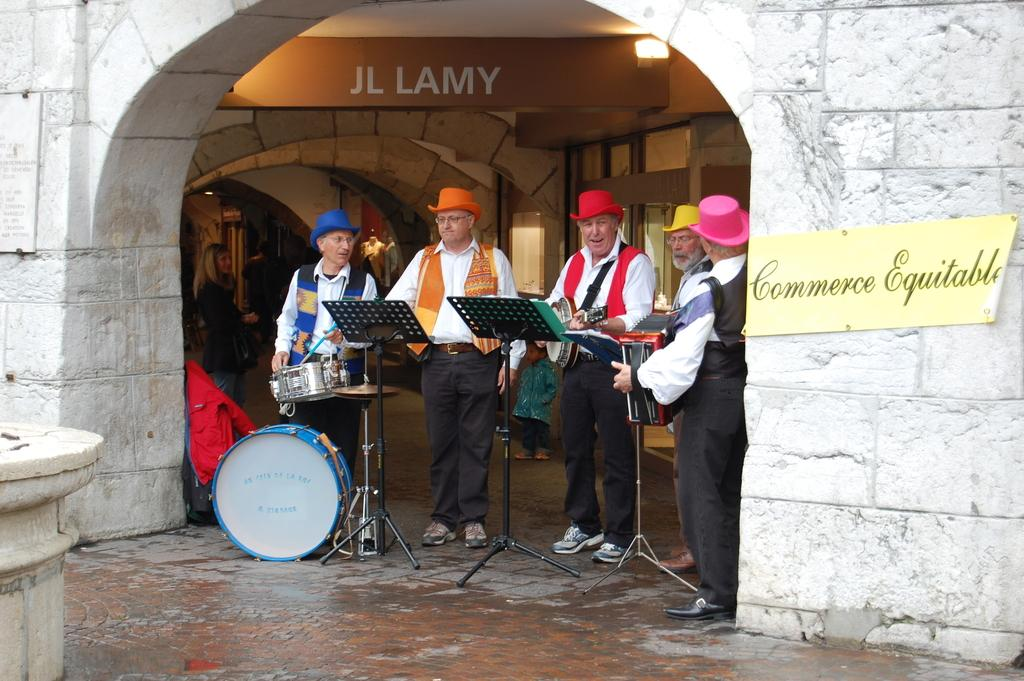What are the people in the image doing? The people in the image are playing musical instruments. Can you describe the setting in which the people are playing their instruments? In the background of the image, there is an arch and a name board. What type of structure is the arch in the image? The arch in the image is a background element and its specific type is not mentioned. What is the condition of the boot in the image? There is no boot present in the image. In what year was the image taken? The year the image was taken is not mentioned in the provided facts. 